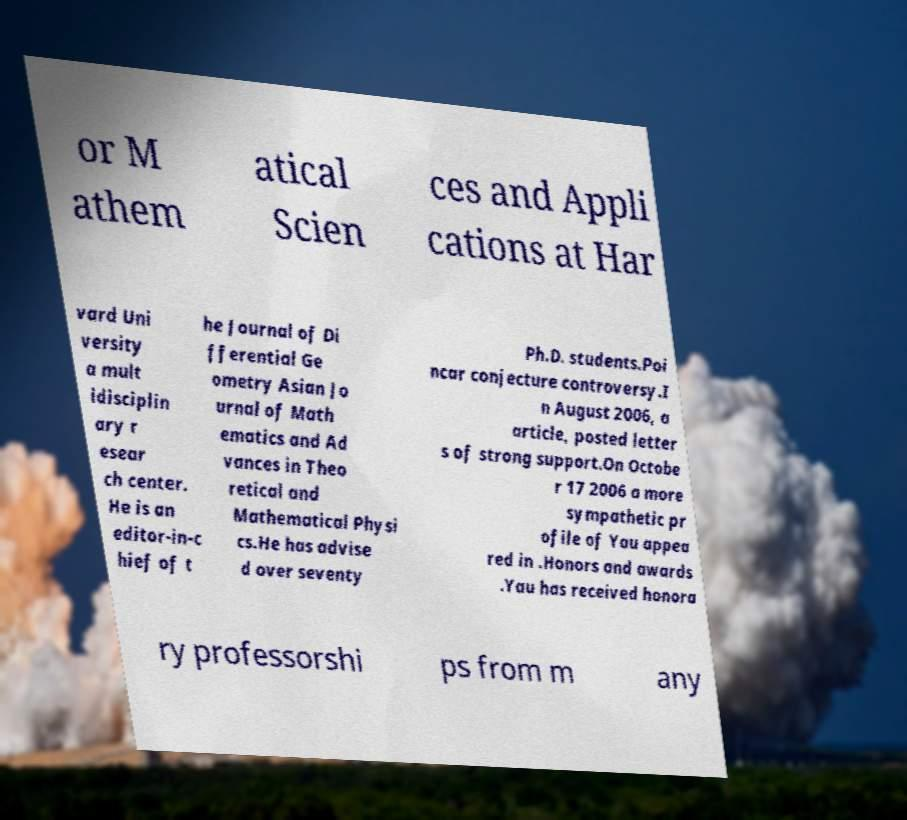I need the written content from this picture converted into text. Can you do that? or M athem atical Scien ces and Appli cations at Har vard Uni versity a mult idisciplin ary r esear ch center. He is an editor-in-c hief of t he Journal of Di fferential Ge ometry Asian Jo urnal of Math ematics and Ad vances in Theo retical and Mathematical Physi cs.He has advise d over seventy Ph.D. students.Poi ncar conjecture controversy.I n August 2006, a article, posted letter s of strong support.On Octobe r 17 2006 a more sympathetic pr ofile of Yau appea red in .Honors and awards .Yau has received honora ry professorshi ps from m any 